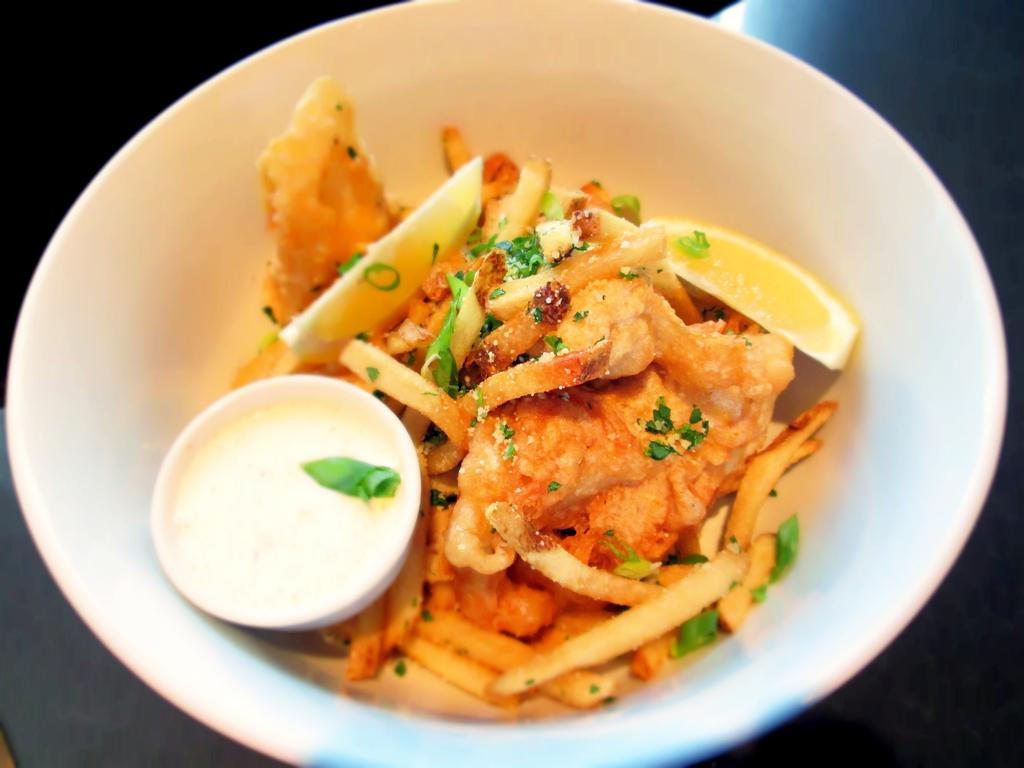What type of food is on the plate in the image? There is a plate with french fries in the image. What is in the bowl that is visible in the image? There is a bowl with cream in the image. What type of vest is the toad wearing in the image? There is no toad or vest present in the image. What policy is the minister discussing in the image? There is no minister or policy discussion present in the image. 